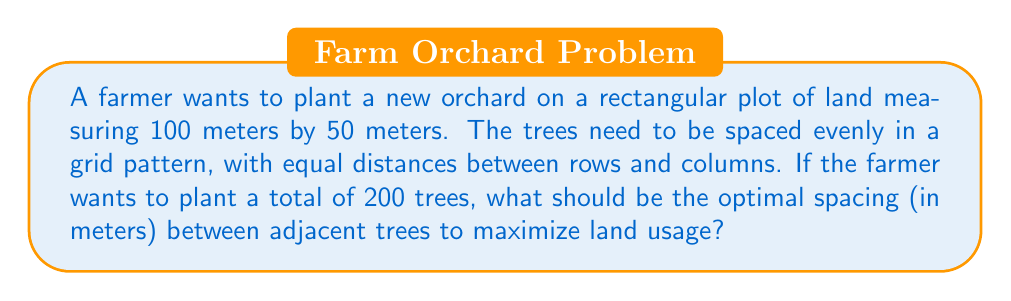Help me with this question. Let's approach this step-by-step:

1) First, we need to determine the number of rows and columns that will give us 200 trees in total. Let's say we have $x$ rows and $y$ columns.

   $x \cdot y = 200$

2) We know that the plot is rectangular, with a length of 100m and width of 50m. The number of spaces between trees will be one less than the number of trees in each direction. So:

   $100 = (y-1) \cdot \text{spacing}$
   $50 = (x-1) \cdot \text{spacing}$

3) Dividing these equations:

   $\frac{100}{50} = \frac{y-1}{x-1}$
   $2 = \frac{y-1}{x-1}$

4) This means $y-1 = 2(x-1)$, or $y = 2x-1$

5) Substituting this into our original equation:

   $x(2x-1) = 200$
   $2x^2 - x - 200 = 0$

6) Solving this quadratic equation:

   $x = \frac{1 + \sqrt{1+1600}}{4} = \frac{1 + \sqrt{1601}}{4} \approx 10$

7) Since $x$ must be an integer, we round to $x = 10$. This means $y = 2(10)-1 = 19$

8) Now we can calculate the spacing:

   $\text{spacing} = \frac{100}{y-1} = \frac{100}{18} = \frac{50}{9} \approx 5.56$ meters

9) We can verify: $9 \cdot 5.56 = 50$ and $18 \cdot 5.56 = 100$, which matches our plot dimensions.

   Also, $10 \cdot 19 = 190$ trees, which is close to our target of 200.
Answer: $\frac{50}{9} \approx 5.56$ meters 